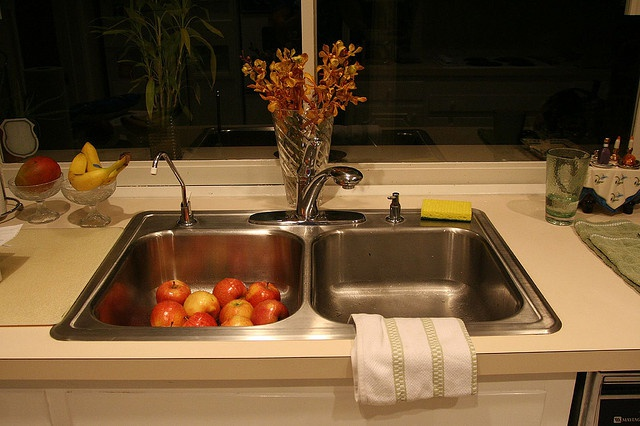Describe the objects in this image and their specific colors. I can see sink in black, maroon, and gray tones, sink in black, maroon, and red tones, apple in black, red, brown, and orange tones, vase in black, maroon, and brown tones, and cup in black and olive tones in this image. 